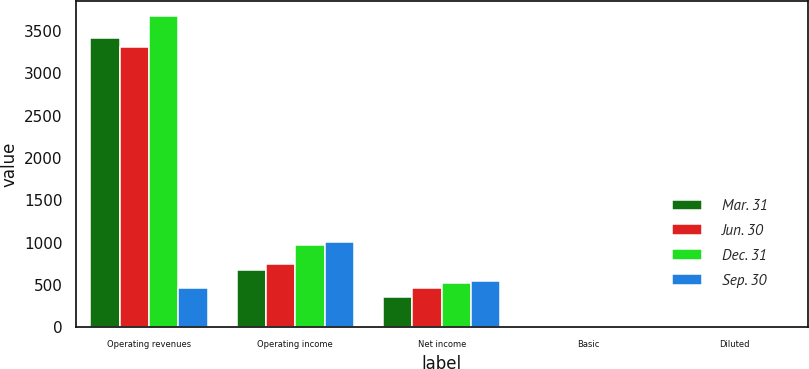Convert chart. <chart><loc_0><loc_0><loc_500><loc_500><stacked_bar_chart><ecel><fcel>Operating revenues<fcel>Operating income<fcel>Net income<fcel>Basic<fcel>Diluted<nl><fcel>Mar. 31<fcel>3415<fcel>672<fcel>362<fcel>0.72<fcel>0.72<nl><fcel>Jun. 30<fcel>3303<fcel>751<fcel>468<fcel>0.93<fcel>0.92<nl><fcel>Dec. 31<fcel>3671<fcel>967<fcel>517<fcel>1.03<fcel>1.02<nl><fcel>Sep. 30<fcel>468<fcel>1002<fcel>551<fcel>1.09<fcel>1.08<nl></chart> 